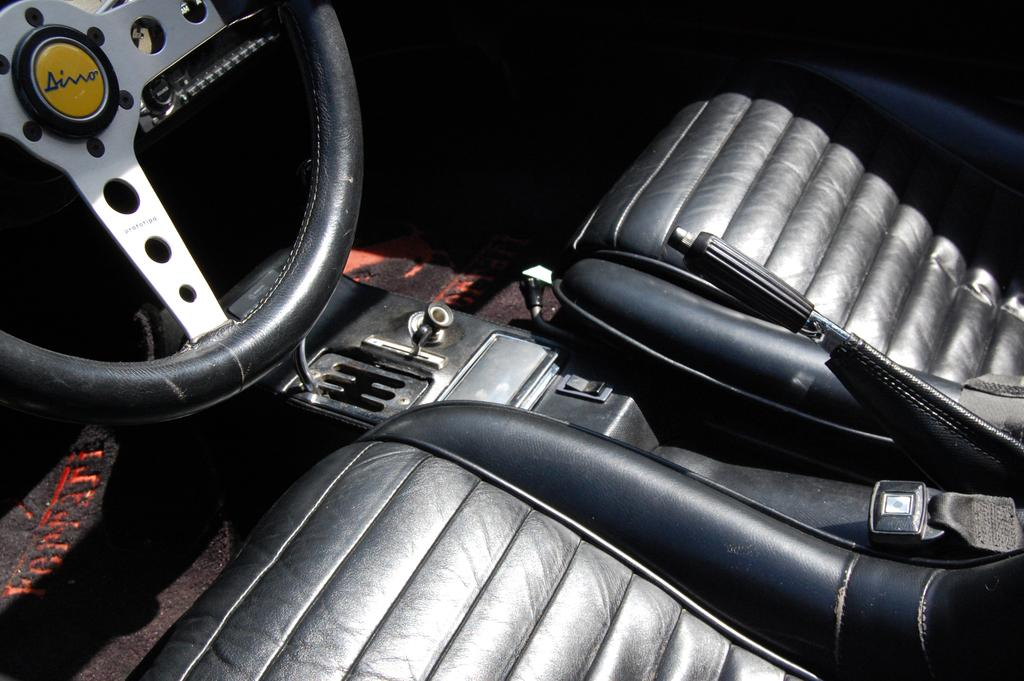What is the main object in the image? There is a steering in the image. What is located in front of the steering? There are two seats in front of the steering. What is present between the seats? There is a hand-brake between the seats. What type of song is being played by the boat in the image? There is no boat or song present in the image; it features a steering, seats, and a hand-brake. How many beads are hanging from the rearview mirror in the image? There is no rearview mirror or beads present in the image. 